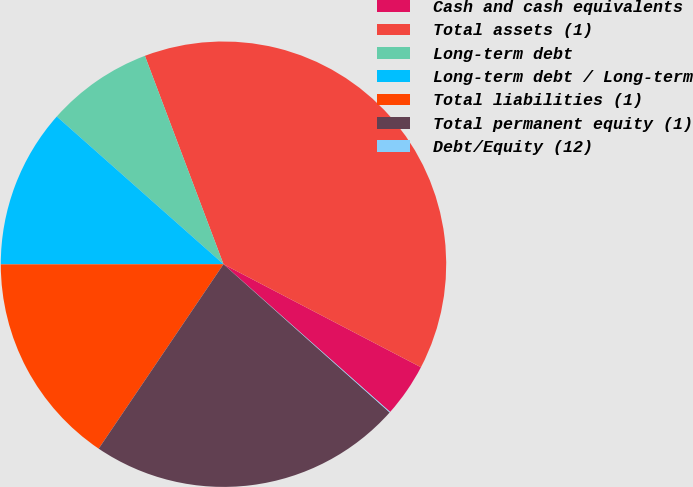Convert chart. <chart><loc_0><loc_0><loc_500><loc_500><pie_chart><fcel>Cash and cash equivalents<fcel>Total assets (1)<fcel>Long-term debt<fcel>Long-term debt / Long-term<fcel>Total liabilities (1)<fcel>Total permanent equity (1)<fcel>Debt/Equity (12)<nl><fcel>3.89%<fcel>38.39%<fcel>7.72%<fcel>11.55%<fcel>15.52%<fcel>22.87%<fcel>0.05%<nl></chart> 